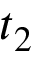Convert formula to latex. <formula><loc_0><loc_0><loc_500><loc_500>t _ { 2 }</formula> 